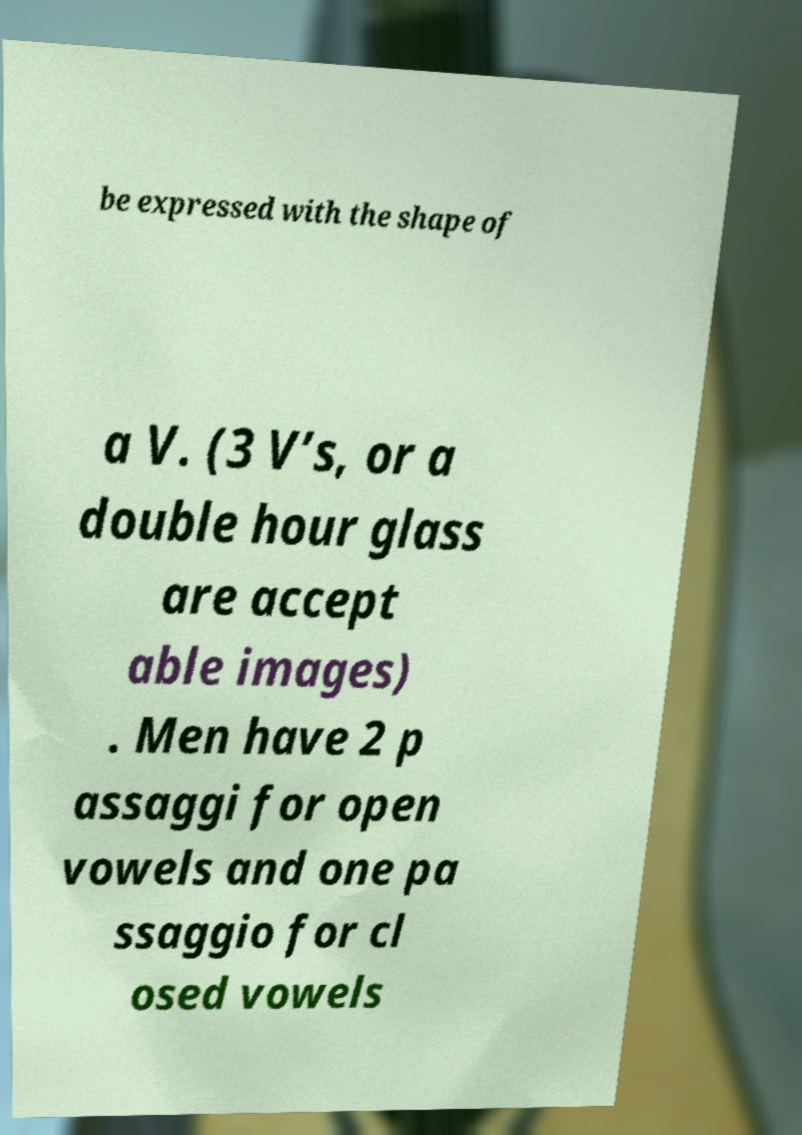Can you read and provide the text displayed in the image?This photo seems to have some interesting text. Can you extract and type it out for me? be expressed with the shape of a V. (3 V’s, or a double hour glass are accept able images) . Men have 2 p assaggi for open vowels and one pa ssaggio for cl osed vowels 